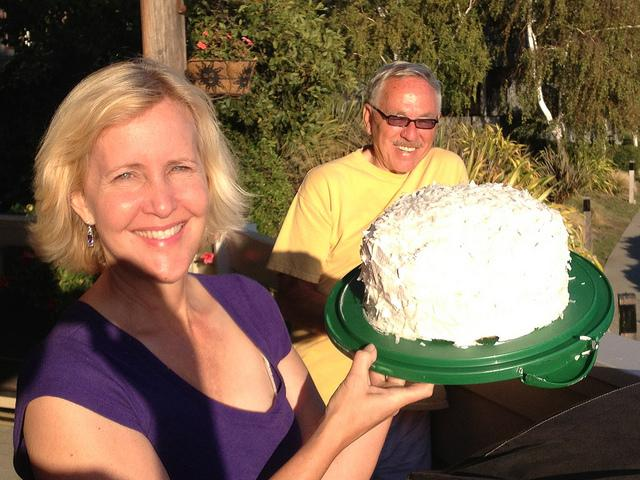The frosting is probably made from what? Please explain your reasoning. buttercream. The frosting is light in color and whipped. 